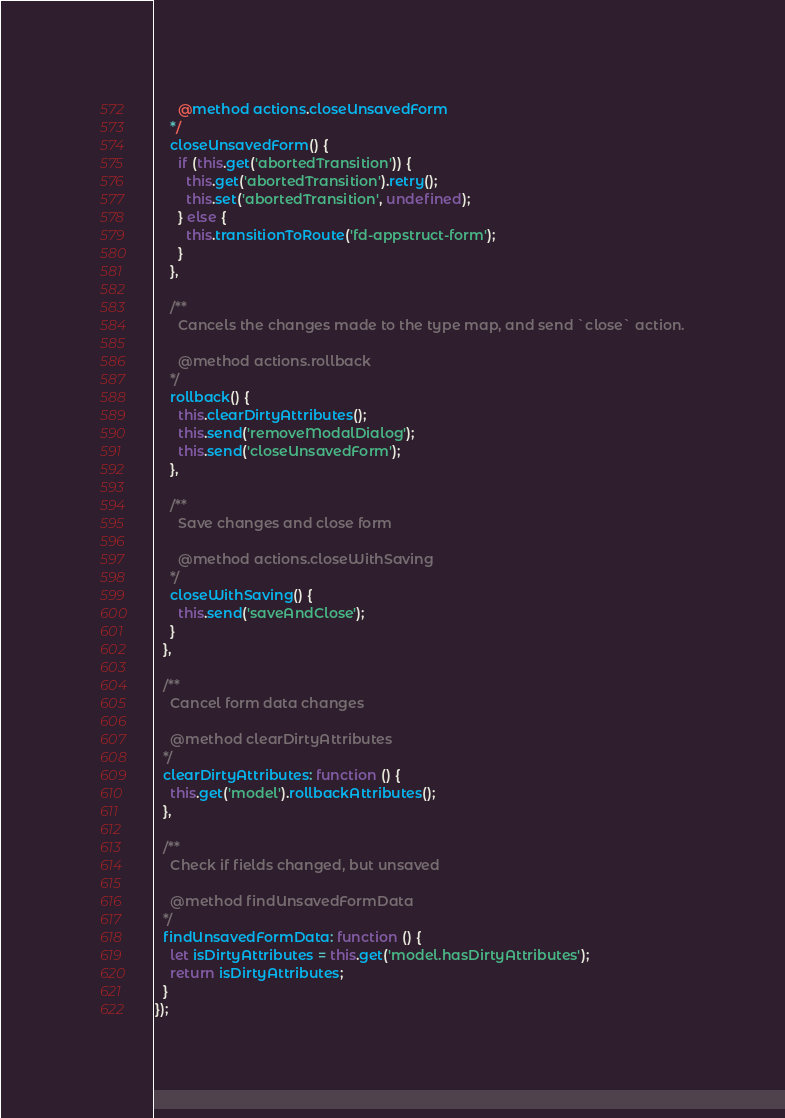Convert code to text. <code><loc_0><loc_0><loc_500><loc_500><_JavaScript_>      @method actions.closeUnsavedForm
    */
    closeUnsavedForm() {
      if (this.get('abortedTransition')) {
        this.get('abortedTransition').retry();
        this.set('abortedTransition', undefined);
      } else {
        this.transitionToRoute('fd-appstruct-form');
      }
    },

    /**
      Cancels the changes made to the type map, and send `close` action.

      @method actions.rollback
    */
    rollback() {
      this.clearDirtyAttributes();
      this.send('removeModalDialog');
      this.send('closeUnsavedForm');
    },

    /**
      Save changes and close form

      @method actions.closeWithSaving
    */
    closeWithSaving() {
      this.send('saveAndClose');
    }
  },

  /**
    Cancel form data changes

    @method clearDirtyAttributes
  */
  clearDirtyAttributes: function () {
    this.get('model').rollbackAttributes();
  },

  /**
    Check if fields changed, but unsaved

    @method findUnsavedFormData
  */
  findUnsavedFormData: function () {
    let isDirtyAttributes = this.get('model.hasDirtyAttributes');
    return isDirtyAttributes;
  }
});
</code> 